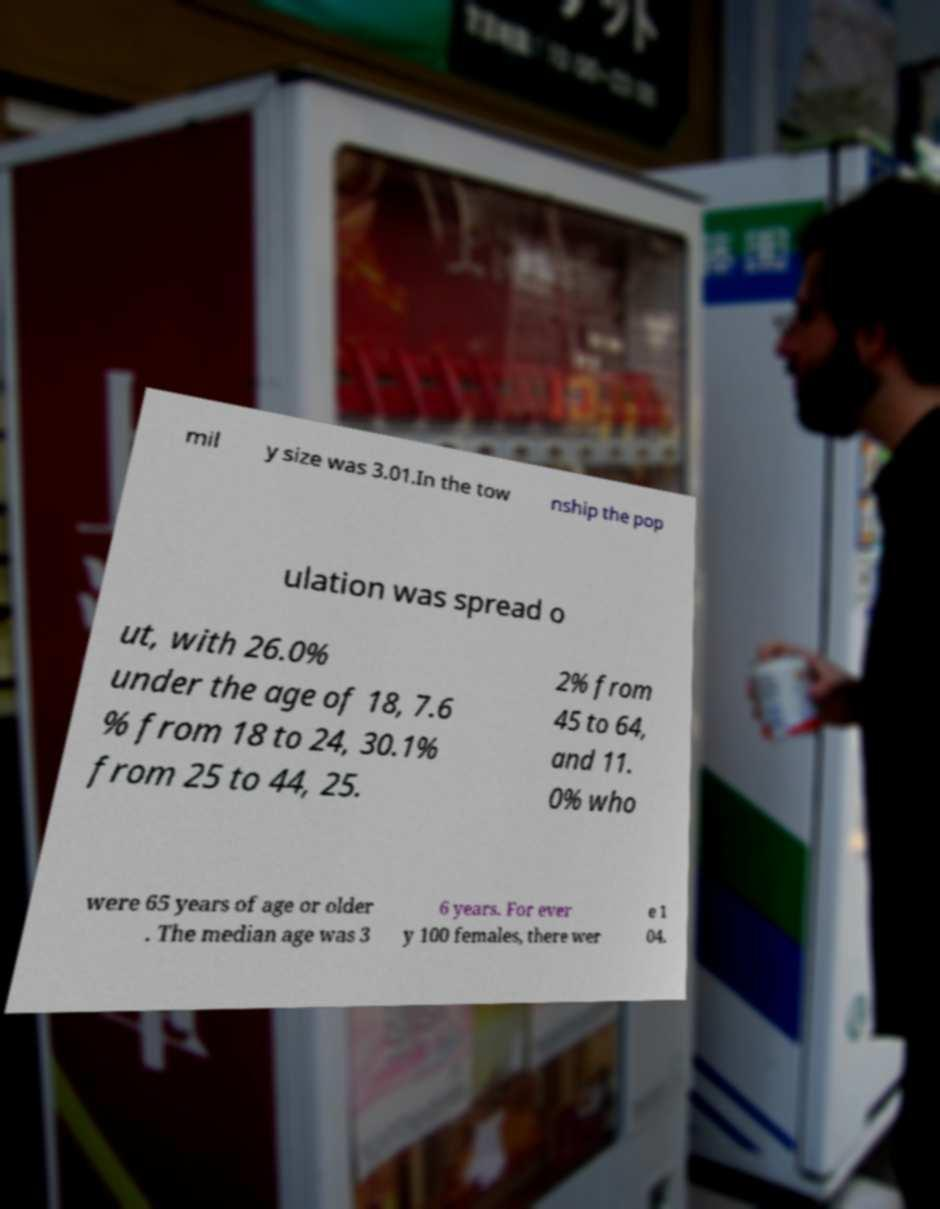Please identify and transcribe the text found in this image. mil y size was 3.01.In the tow nship the pop ulation was spread o ut, with 26.0% under the age of 18, 7.6 % from 18 to 24, 30.1% from 25 to 44, 25. 2% from 45 to 64, and 11. 0% who were 65 years of age or older . The median age was 3 6 years. For ever y 100 females, there wer e 1 04. 